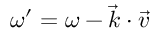Convert formula to latex. <formula><loc_0><loc_0><loc_500><loc_500>\omega ^ { \prime } = \omega - \overrightarrow { k } \cdot \overrightarrow { v }</formula> 